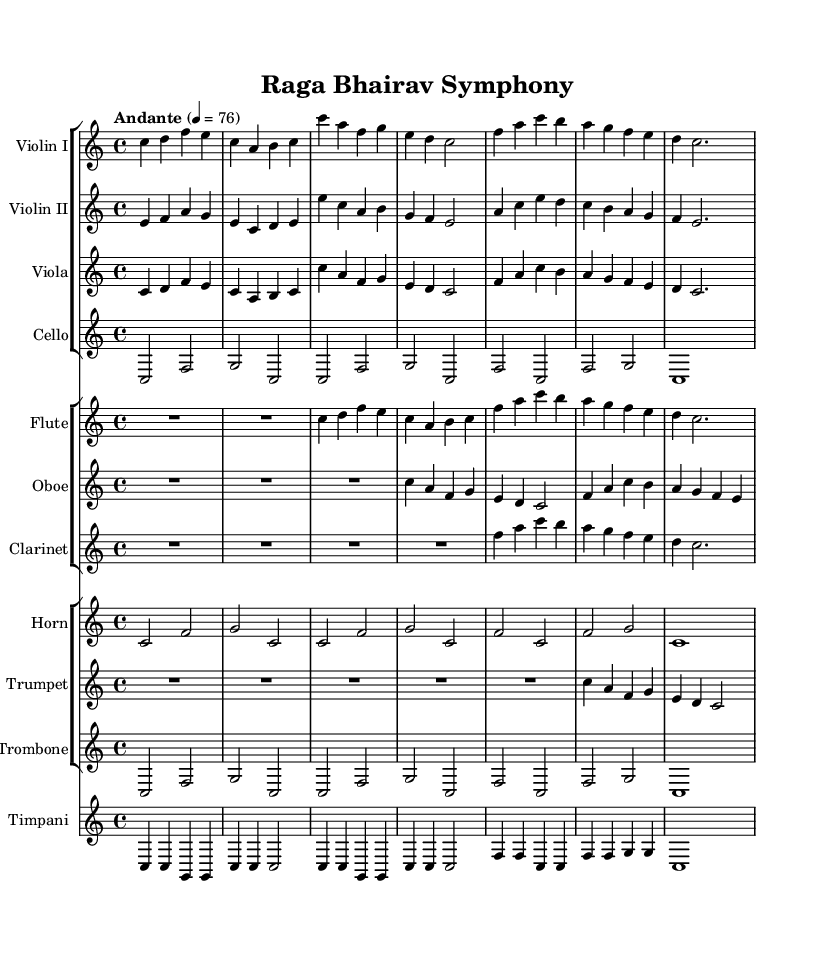What is the key signature of this music? The key signature is indicated at the beginning of the staff, which shows no sharps or flats, confirming the piece is in C major.
Answer: C major What is the time signature of this music? The time signature appears at the beginning of the score, represented as 4/4, which indicates four beats per measure.
Answer: 4/4 What is the tempo marking of this piece? The tempo marking is written above the staff, showing "Andante" with a metronome marking of 76 beats per minute, giving the piece a moderately slow tempo.
Answer: Andante, 76 How many instruments are included in the symphony? By counting each staff group in the score, we see a total of eight different instruments, thus indicating the ensemble's size.
Answer: Eight Which instrument starts with a rest of 2 beats? The flute notates a rest for a whole measure initially, which is annotated as R1*2, meaning it starts playing after the first two beats of the first measure.
Answer: Flute In which section is the timpani located in the score? The timpani is notated as a different staff underneath the brass section and woodwind section, indicating that it belongs to the percussion family.
Answer: Percussion What is the overall structure in terms of sections for this symphonic composition? The score is segmented into various staff groups representing strings, woodwinds, brass, and percussion, which is typical for orchestral symphonic arrangements.
Answer: Four sections 